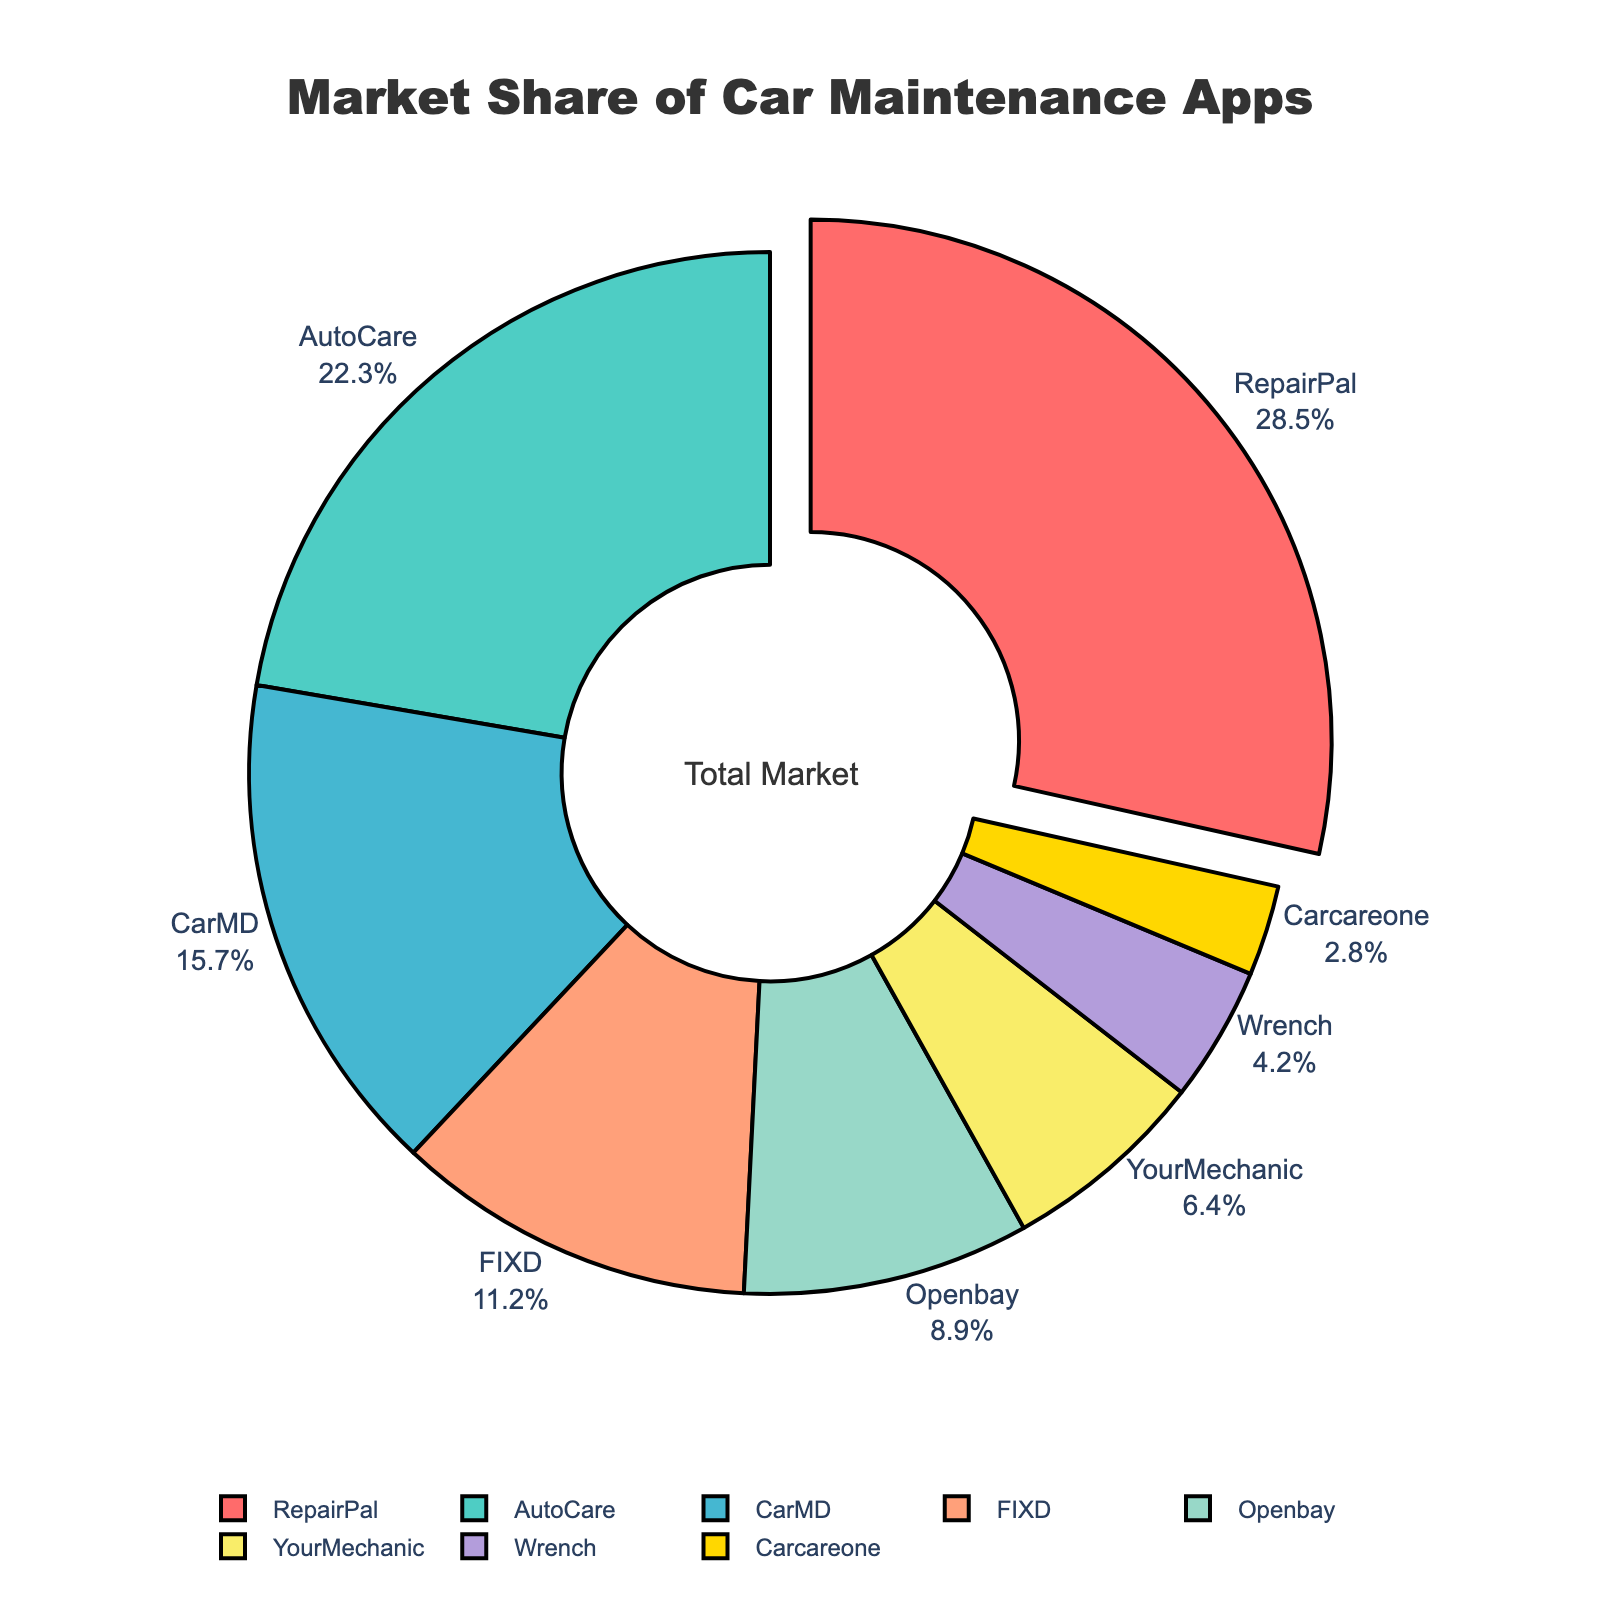Which company has the largest market share? The largest segment in the pie chart represents the company with the largest market share. In this case, the pulled-out slice shows the company as RepairPal.
Answer: RepairPal How much market share do the top two companies collectively hold? Add the market share percentages of RepairPal and AutoCare. RepairPal has 28.5% and AutoCare has 22.3%, making the total 28.5% + 22.3% = 50.8%.
Answer: 50.8% Which company has a smaller market share, FIXD or YourMechanic? Compare the market share percentages of FIXD (11.2%) and YourMechanic (6.4%) in the pie chart. FIXD has a higher percentage than YourMechanic, so YourMechanic has the smaller market share.
Answer: YourMechanic How does the market share of CarMD compare to Openbay? Compare the market share percentages of CarMD and Openbay. CarMD has 15.7% while Openbay has 8.9%. CarMD has a larger market share than Openbay.
Answer: CarMD What is the combined market share of Wrench and Carcareone? Add the market share percentages of Wrench and Carcareone. Wrench has 4.2% and Carcareone has 2.8%, so the total is 4.2% + 2.8% = 7%.
Answer: 7% What is the difference in market share between the largest and the smallest company? Subtract the market share of the smallest company (Carcareone with 2.8%) from the largest company (RepairPal with 28.5%). The difference is 28.5% - 2.8% = 25.7%.
Answer: 25.7% What percentage of the market is held by companies other than the top three? Subtract the combined market share of the top three companies (RepairPal, AutoCare, and CarMD) from 100%. The top three's total is 28.5% + 22.3% + 15.7% = 66.5%, so the remaining is 100% - 66.5% = 33.5%.
Answer: 33.5% Which company represented by a blue slice has a market share of 11.2%? The blue slice corresponds to FIXD, as it is visually marked in blue and has a market share of 11.2%.
Answer: FIXD What is the market share of the company represented by the yellow slice? The yellow slice corresponds to Openbay. Looking at the pie chart, Openbay holds a market share of 8.9%.
Answer: 8.9% How many companies have a market share of less than 10%? Identify and count the companies with a market share less than 10%. These are Openbay (8.9%), YourMechanic (6.4%), Wrench (4.2%), and Carcareone (2.8%). There are 4 companies.
Answer: 4 companies 